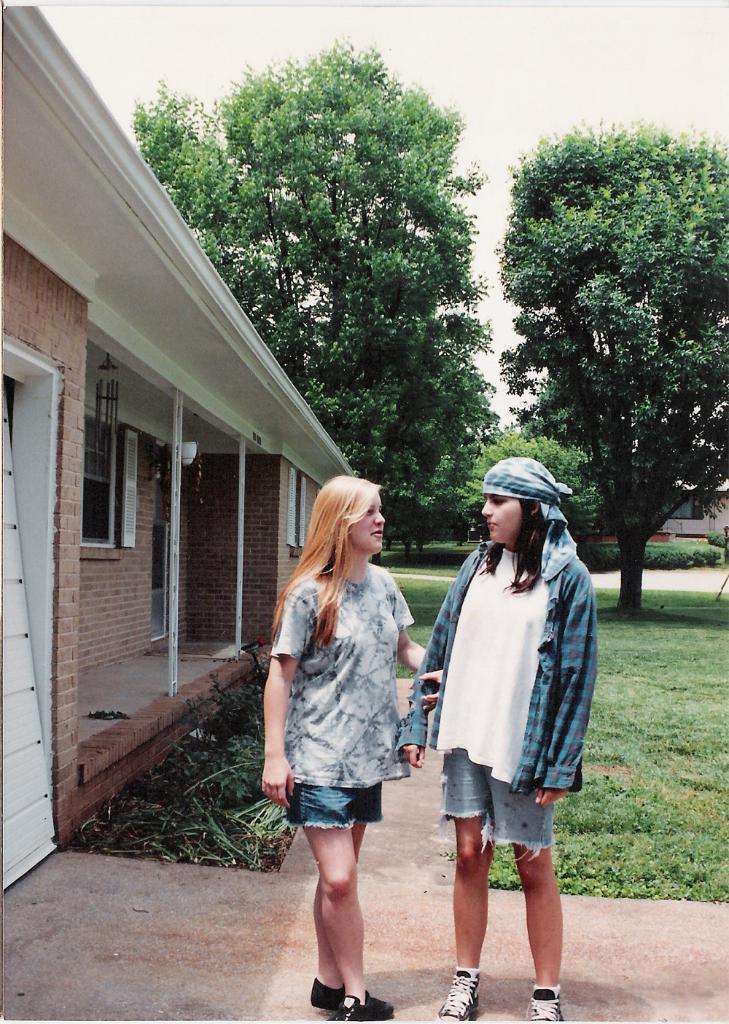Describe this image in one or two sentences. In front of the image there are two people standing. At the bottom of the image there is grass on the surface. There are buildings, trees. At the top of the image there is sky. 